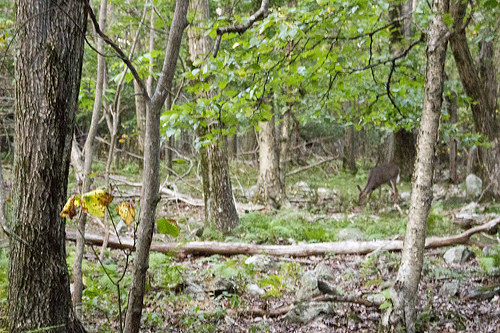<image>
Can you confirm if the tree is under the other tree? Yes. The tree is positioned underneath the other tree, with the other tree above it in the vertical space. 